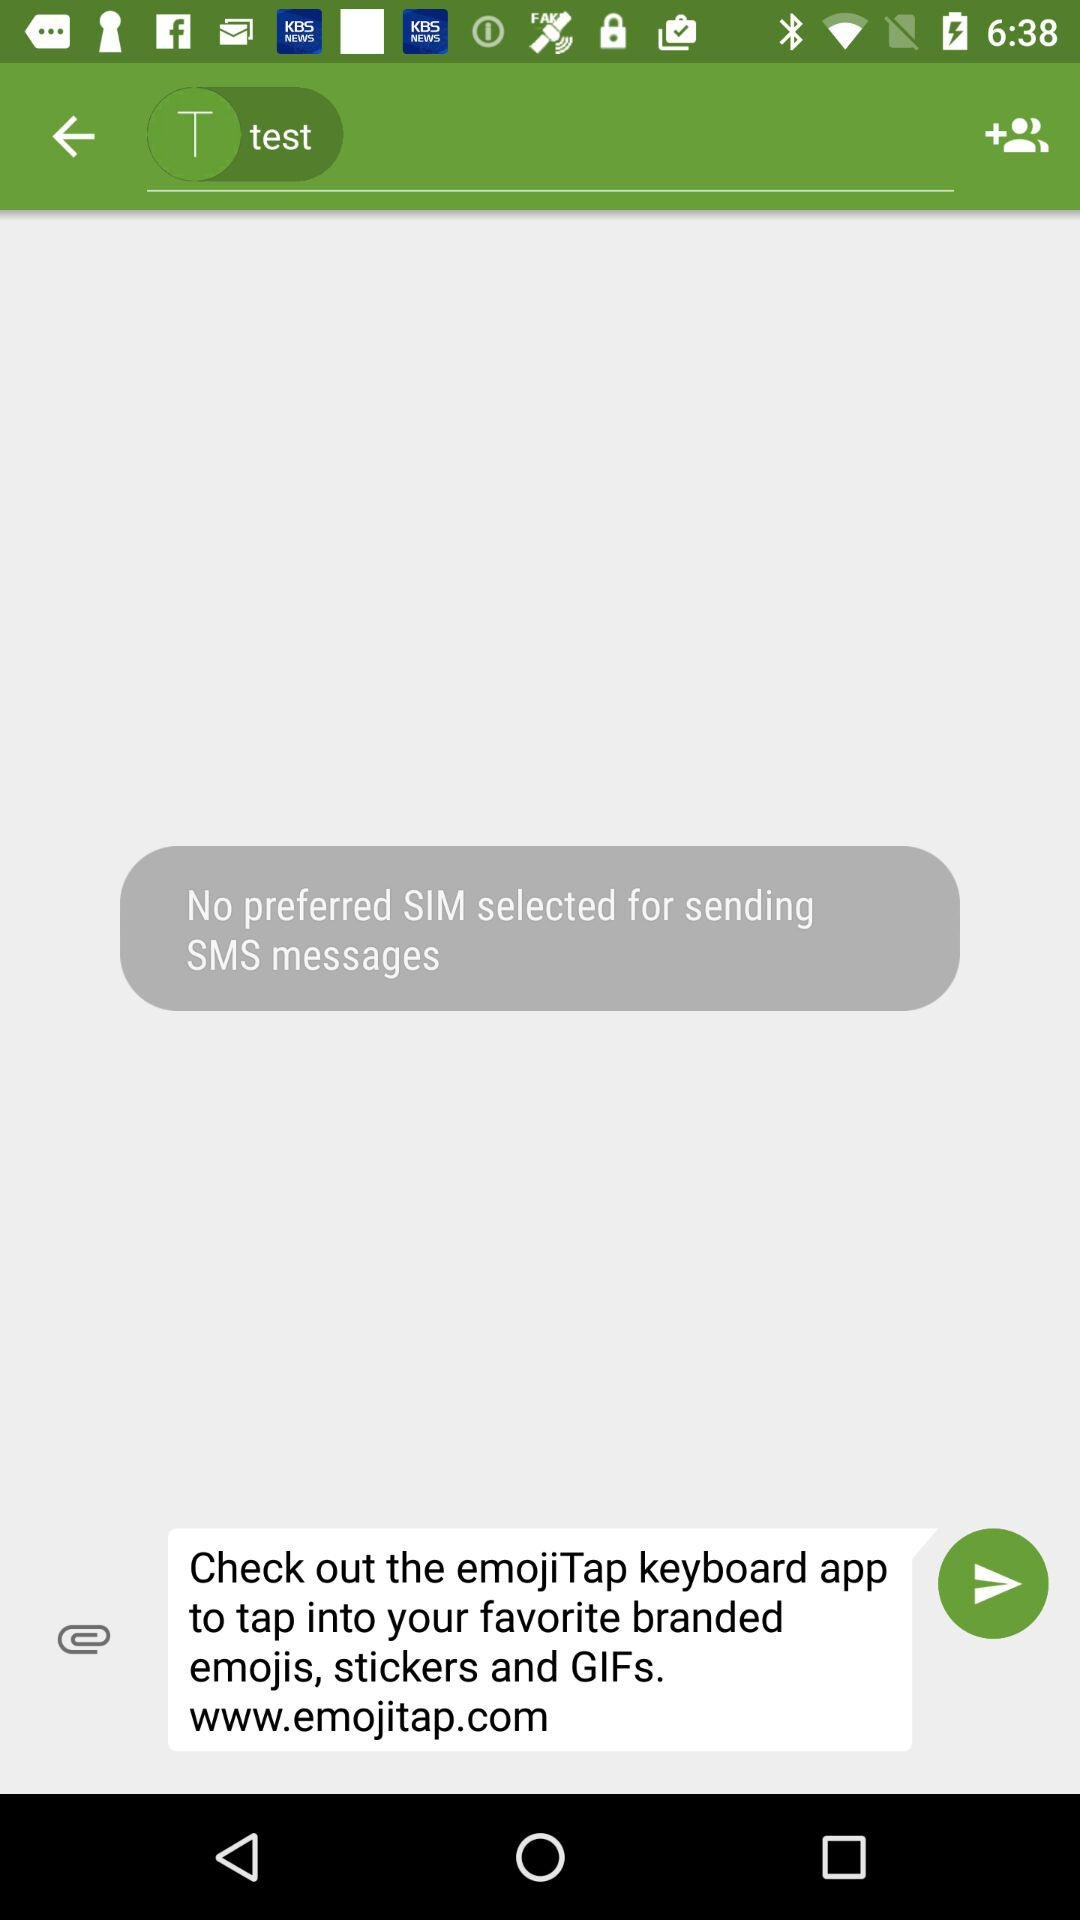Is there any preferred SIM? There is no preferred SIM. 